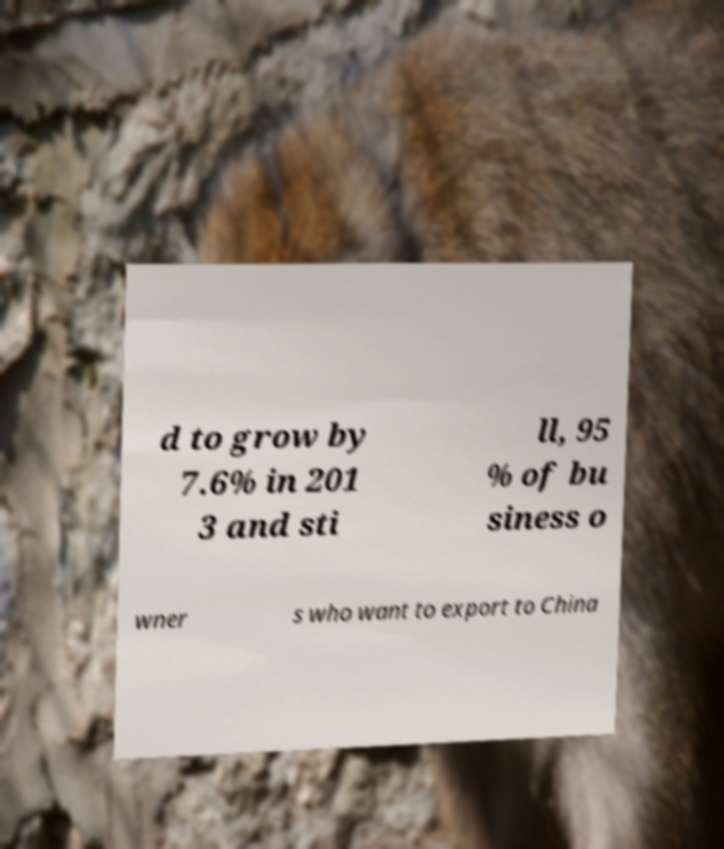Can you read and provide the text displayed in the image?This photo seems to have some interesting text. Can you extract and type it out for me? d to grow by 7.6% in 201 3 and sti ll, 95 % of bu siness o wner s who want to export to China 